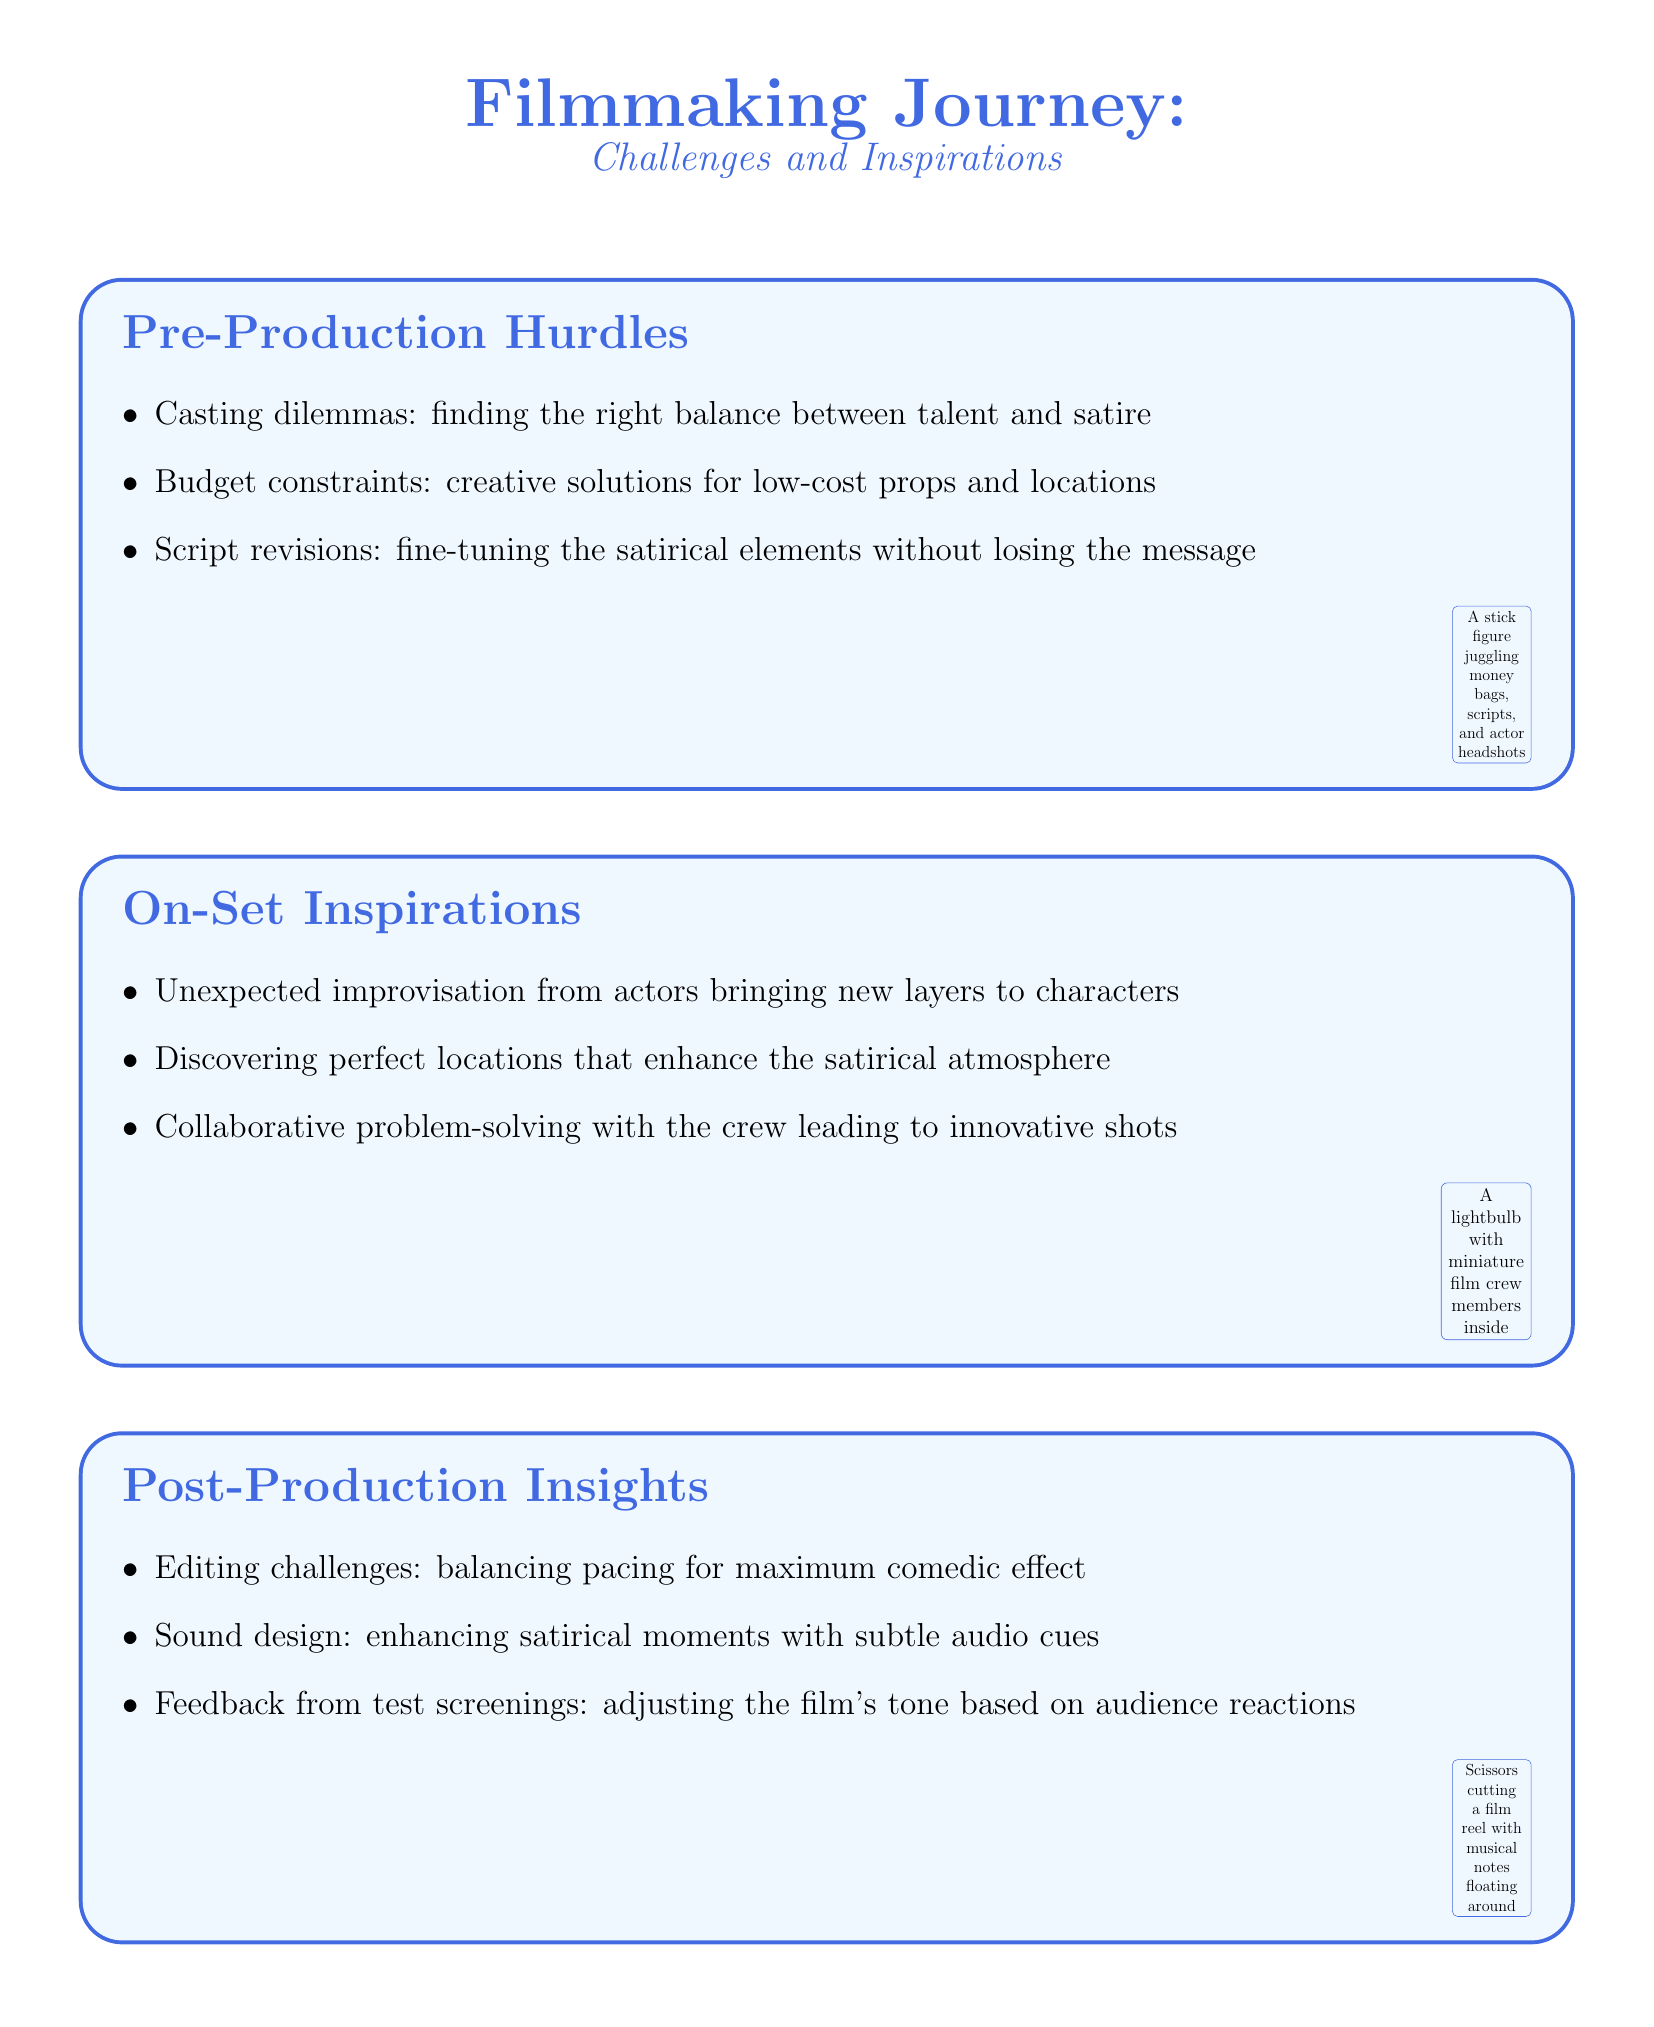What are the pre-production hurdles? The pre-production hurdles include casting dilemmas, budget constraints, and script revisions.
Answer: casting dilemmas, budget constraints, script revisions What inspires filmmakers on set? Filmmakers are inspired by unexpected improvisation from actors, discovering perfect locations, and collaborative problem-solving.
Answer: unexpected improvisation, perfect locations, collaborative problem-solving What do filmmakers balance in post-production? In post-production, filmmakers balance editing challenges, sound design, and feedback from test screenings.
Answer: editing challenges, sound design, feedback from test screenings What are key aspects of collaboration with the illustrator? Key aspects include brainstorming sessions, integrating hand-drawn elements, and maintaining consistent style.
Answer: brainstorming sessions, integrating hand-drawn elements, maintaining consistent style What personal growths are noted? Personal growth includes developing a keener eye for visual irony, balancing artistic vision, and gaining confidence in directing.
Answer: developing a keener eye for visual irony, balancing artistic vision, gaining confidence in directing 